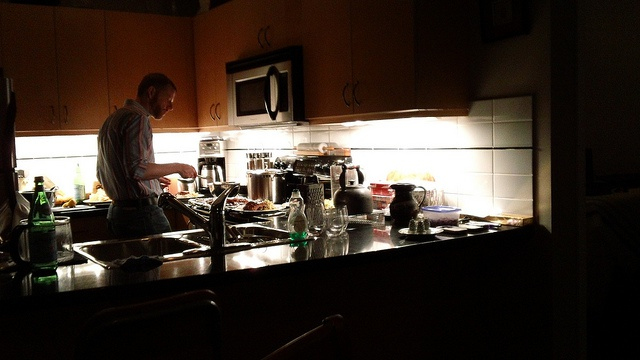Describe the objects in this image and their specific colors. I can see people in black, maroon, and gray tones, chair in black and darkgray tones, microwave in black, maroon, and tan tones, sink in black, white, gray, and darkgray tones, and bottle in black, darkgreen, gray, and green tones in this image. 